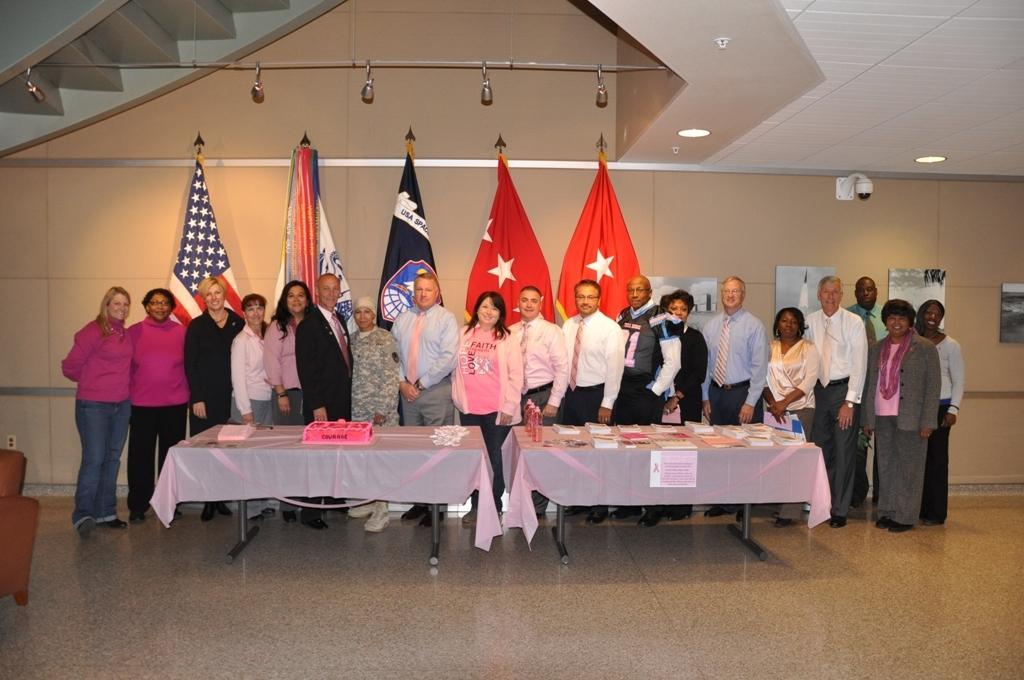Describe this image in one or two sentences. in the picture there are many people standing in front of table,there are many flags back of them on the wall. 